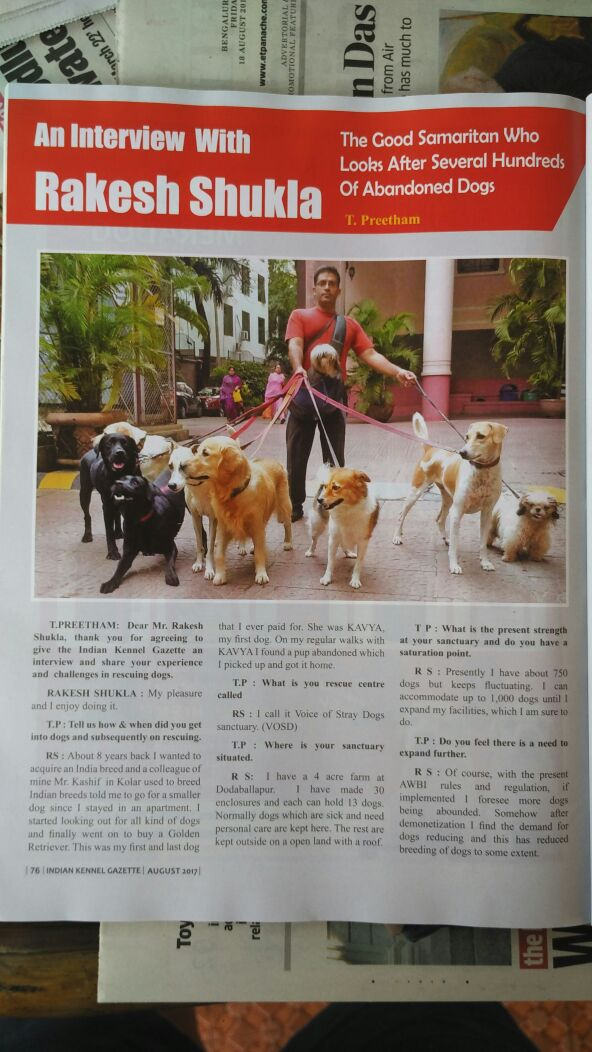Based on the text visible in the image, what could be the primary motivation for Rakesh Shukla to engage in the rescue and care of stray dogs, and how has he structured the environment for the dogs based on the details provided in the interview excerpt? Rakesh Shukla's primary motivation to engage in the rescue and care of stray dogs appears to be driven by a deep sense of compassion and a genuine desire to help animals in need. This is evident from the interview where he shares his story of rescuing a pup named KAVYA, which triggered his commitment to rescue dogs. Described as a 'Good sharegpt4v/samaritan', his actions reflect his empathy and dedication to this cause. He has structured a well-organized environment for the dogs at his 4-acre farm in Dobbaspet, which he calls the Voice of Stray Dogs sanctuary (VOSD). The facility includes 30 enclosures, each capable of housing 13 dogs, providing both communal living spaces and open areas where the dogs can roam and interact, ensuring they have a safe and comfortable habitat. 